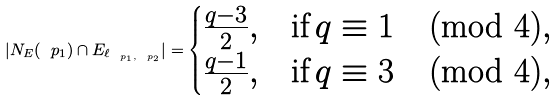Convert formula to latex. <formula><loc_0><loc_0><loc_500><loc_500>| N _ { E } ( \ p _ { 1 } ) \cap E _ { \ell _ { \ p _ { 1 } , \ p _ { 2 } } } | = \begin{cases} \frac { q - 3 } { 2 } , & \text {if} \, q \equiv 1 \pmod { 4 } , \\ \frac { q - 1 } { 2 } , & \text {if} \, q \equiv 3 \pmod { 4 } , \\ \end{cases}</formula> 